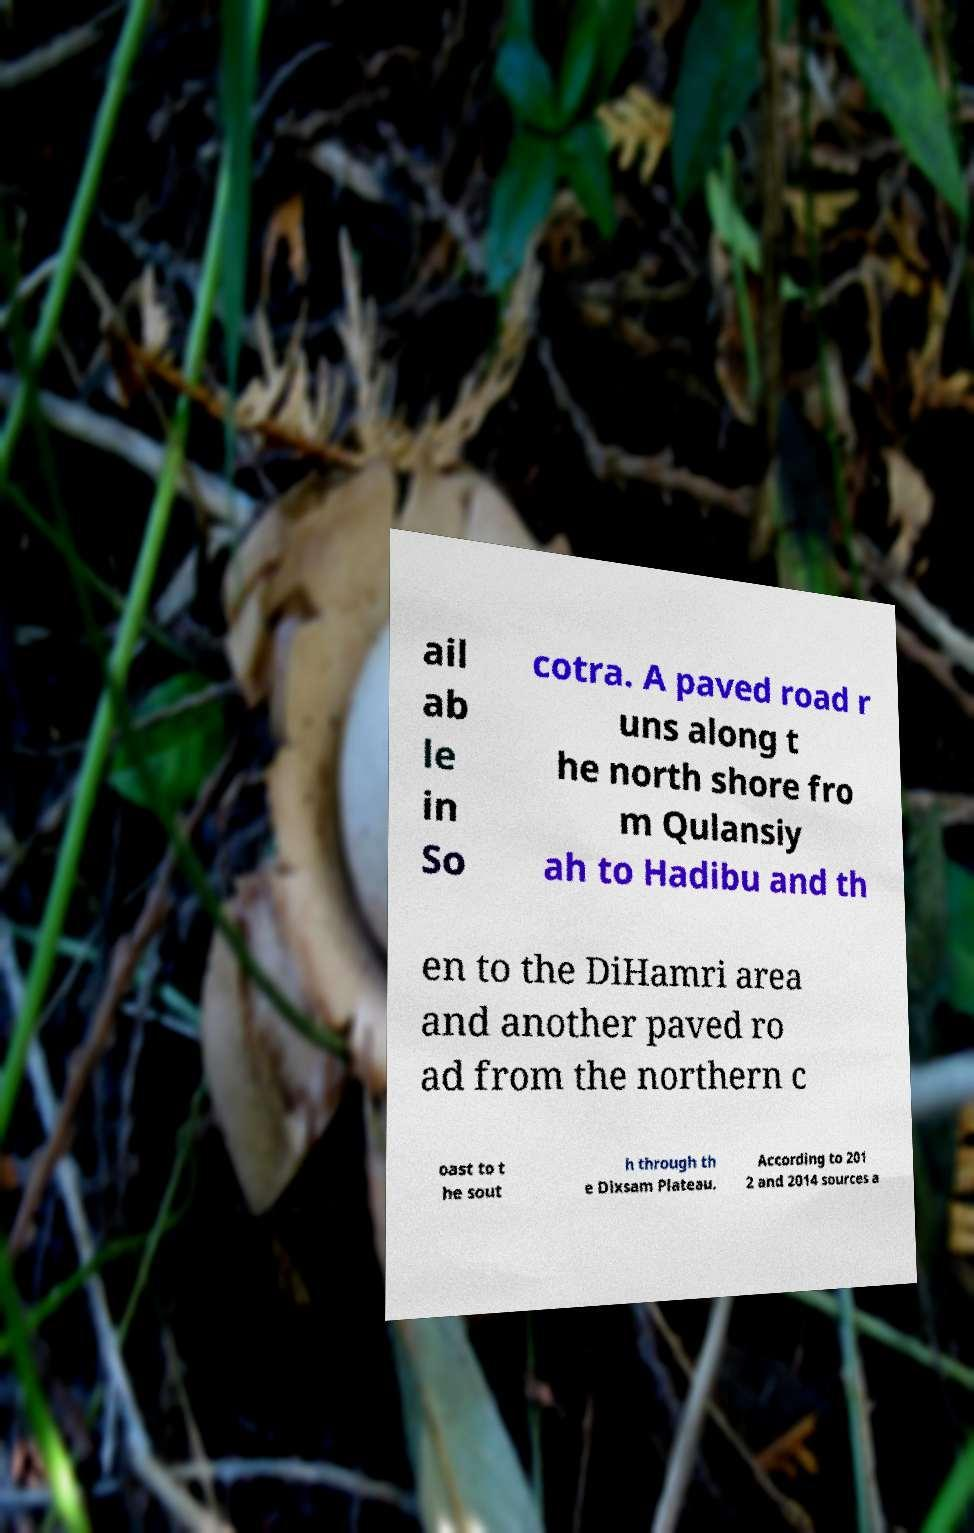Please identify and transcribe the text found in this image. ail ab le in So cotra. A paved road r uns along t he north shore fro m Qulansiy ah to Hadibu and th en to the DiHamri area and another paved ro ad from the northern c oast to t he sout h through th e Dixsam Plateau. According to 201 2 and 2014 sources a 